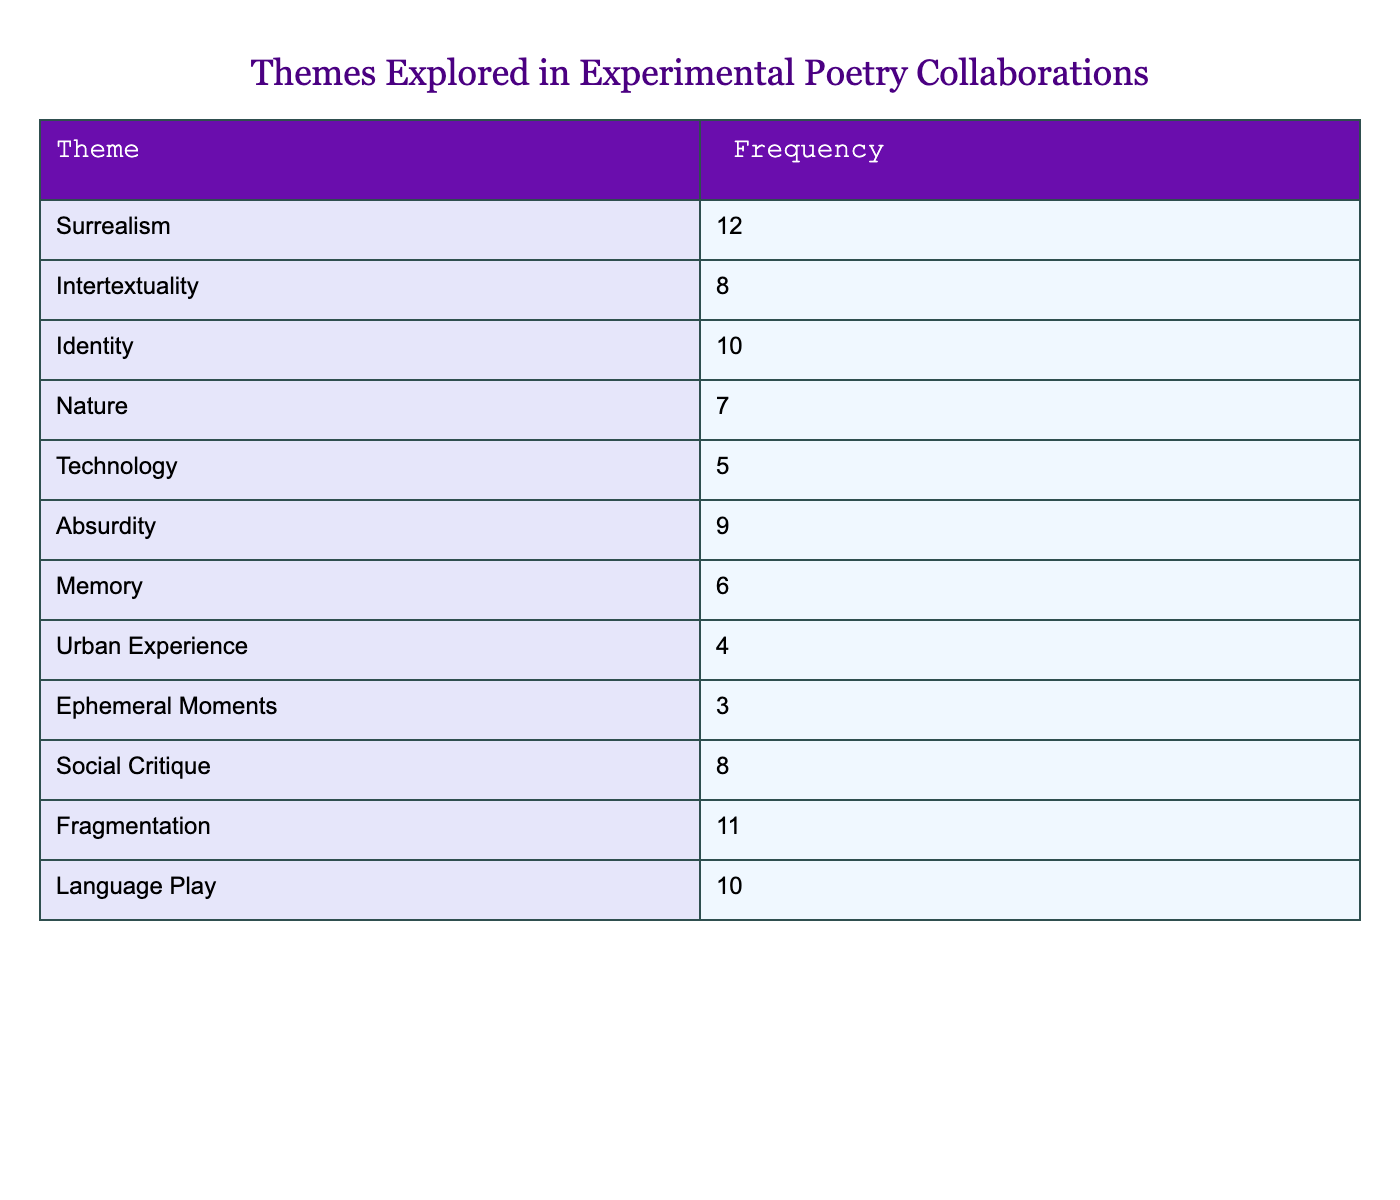What is the frequency of the theme "Surrealism"? The table lists the frequency values alongside their corresponding themes. For "Surrealism," we can directly see that the frequency is 12.
Answer: 12 Which theme has the lowest frequency? By comparing the frequency values of all themes, we find that "Ephemeral Moments" has the lowest frequency at 3.
Answer: Ephemeral Moments How many themes have a frequency greater than 8? We can list the themes with frequencies greater than 8 by looking through the table: "Surrealism," "Identity," "Absurdity," "Fragmentation," and "Language Play," which totals to 5 themes.
Answer: 5 What is the total frequency of the themes "Nature," "Urban Experience," and "Memory"? First, we find the frequencies of these themes: "Nature" is 7, "Urban Experience" is 4, and "Memory" is 6. Next, we sum them up: 7 + 4 + 6 = 17.
Answer: 17 Is the frequency of "Technology" greater than the frequency of "Social Critique"? "Technology" has a frequency of 5 while "Social Critique" has a frequency of 8. Since 5 is not greater than 8, the answer is no.
Answer: No What is the average frequency of the themes listed? To calculate the average frequency, we first sum all the frequencies: 12 + 8 + 10 + 7 + 5 + 9 + 6 + 4 + 3 + 8 + 11 + 10 = 81. Then, we divide by the number of themes, which is 12: 81 / 12 = 6.75.
Answer: 6.75 How many themes explore the concept of identity? The theme "Identity" appears explicitly in the table with a frequency of 10, indicating that it is explored in collaborations. Thus, there is one theme that addresses it.
Answer: 1 Which theme has a frequency that is 2 more than "Absurdity"? "Absurdity" has a frequency of 9. To find the theme that has a frequency of 11 (which is 2 more), we look through the table and find that "Fragmentation" has this frequency of 11.
Answer: Fragmentation 